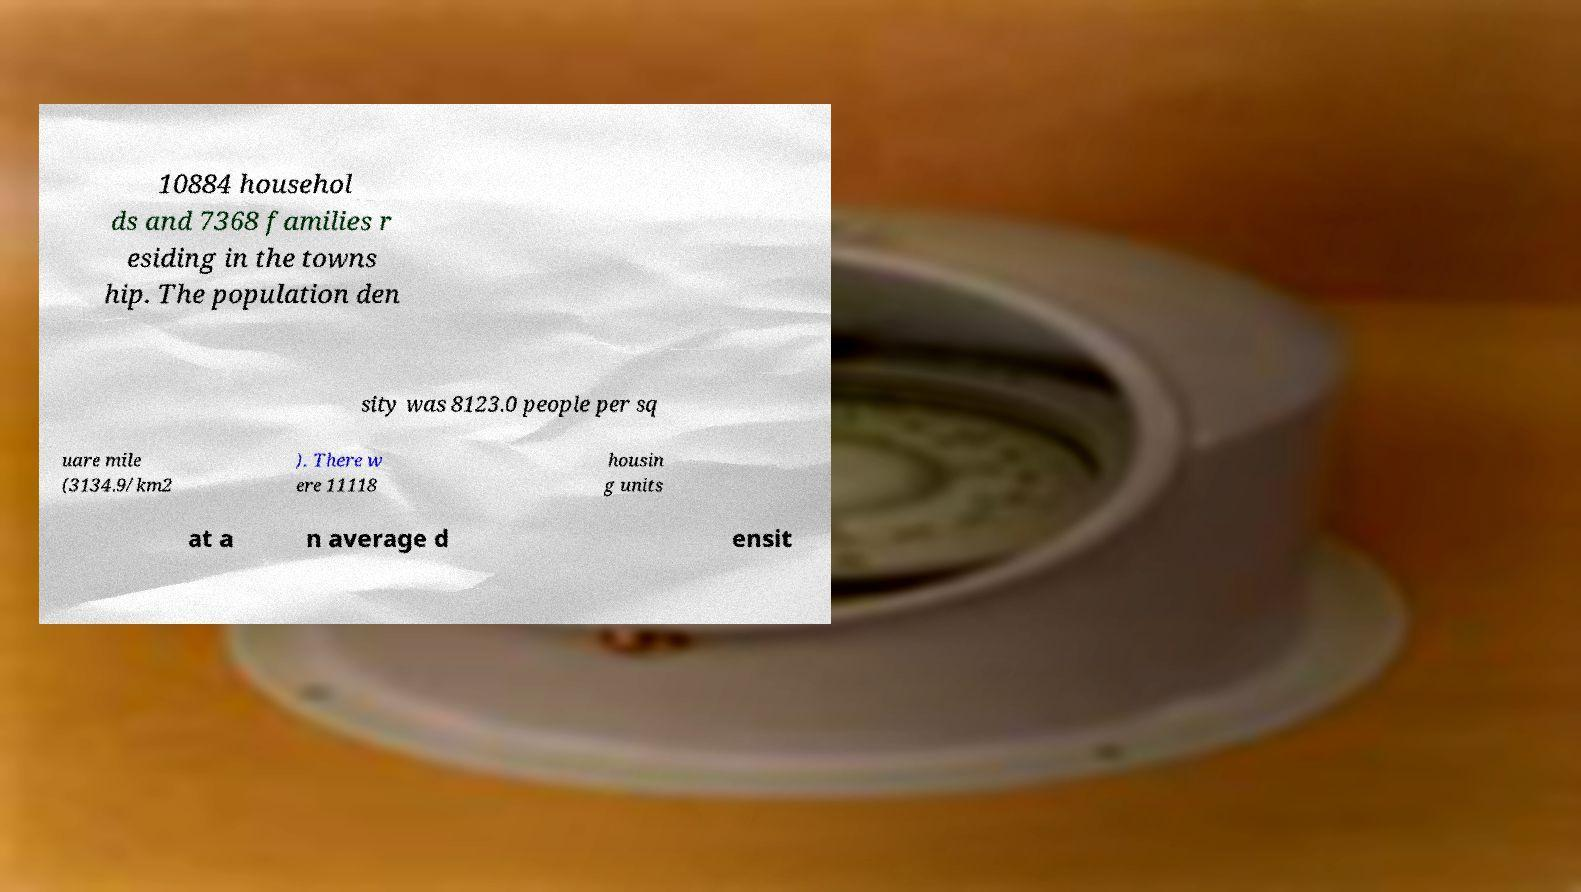Could you assist in decoding the text presented in this image and type it out clearly? 10884 househol ds and 7368 families r esiding in the towns hip. The population den sity was 8123.0 people per sq uare mile (3134.9/km2 ). There w ere 11118 housin g units at a n average d ensit 